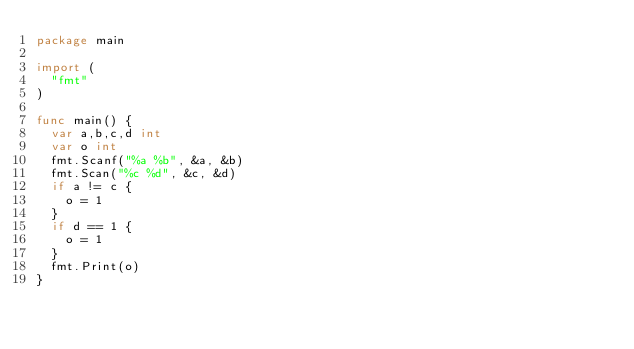Convert code to text. <code><loc_0><loc_0><loc_500><loc_500><_Go_>package main
 
import (
	"fmt"
)

func main() {
	var a,b,c,d int
	var o int
	fmt.Scanf("%a %b", &a, &b)
	fmt.Scan("%c %d", &c, &d)
	if a != c {
		o = 1
	}
	if d == 1 {
		o = 1
	}
	fmt.Print(o)
}</code> 